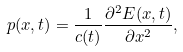<formula> <loc_0><loc_0><loc_500><loc_500>p ( x , t ) = \frac { 1 } { c ( t ) } \frac { \partial ^ { 2 } E ( x , t ) } { \partial x ^ { 2 } } ,</formula> 